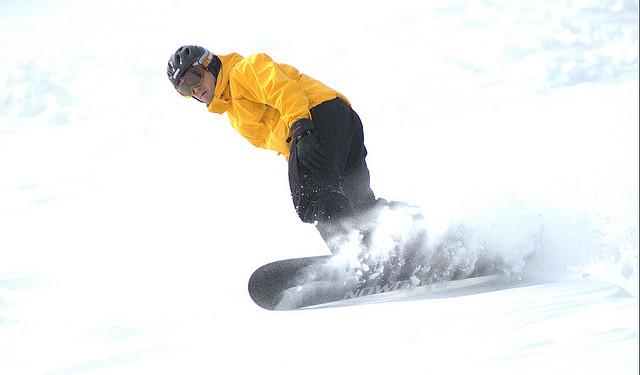What sport is he participating in?
Write a very short answer. Snowboarding. Is that powder snow?
Concise answer only. Yes. Is the man in motion?
Quick response, please. Yes. 